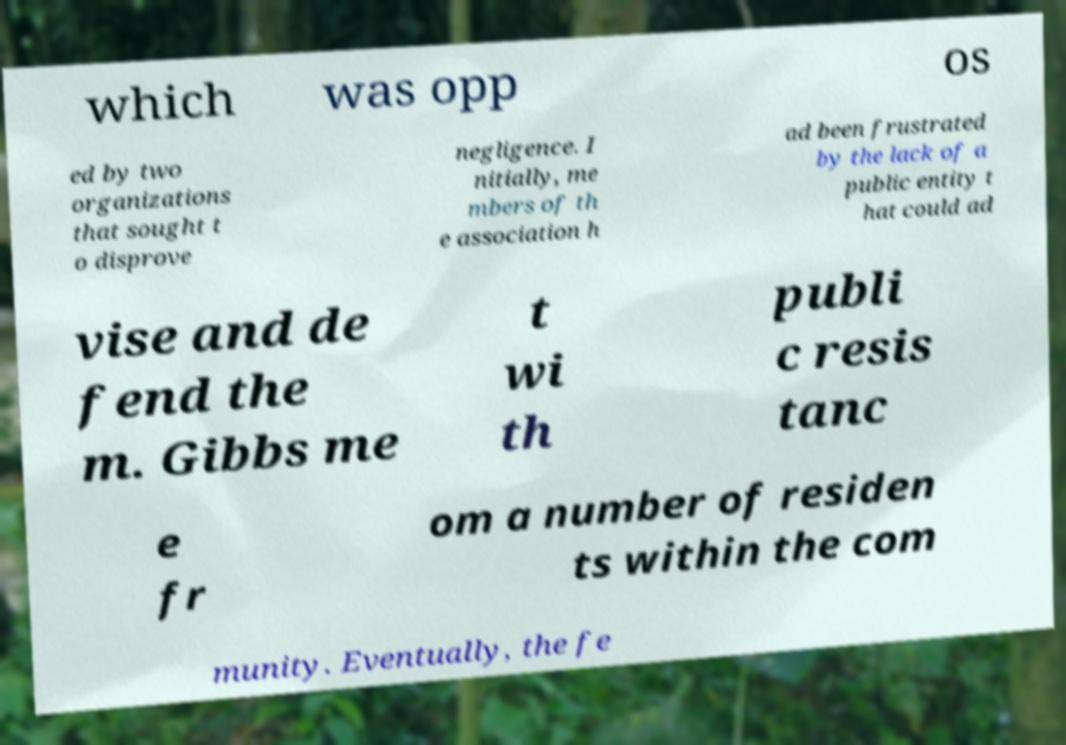What messages or text are displayed in this image? I need them in a readable, typed format. which was opp os ed by two organizations that sought t o disprove negligence. I nitially, me mbers of th e association h ad been frustrated by the lack of a public entity t hat could ad vise and de fend the m. Gibbs me t wi th publi c resis tanc e fr om a number of residen ts within the com munity. Eventually, the fe 